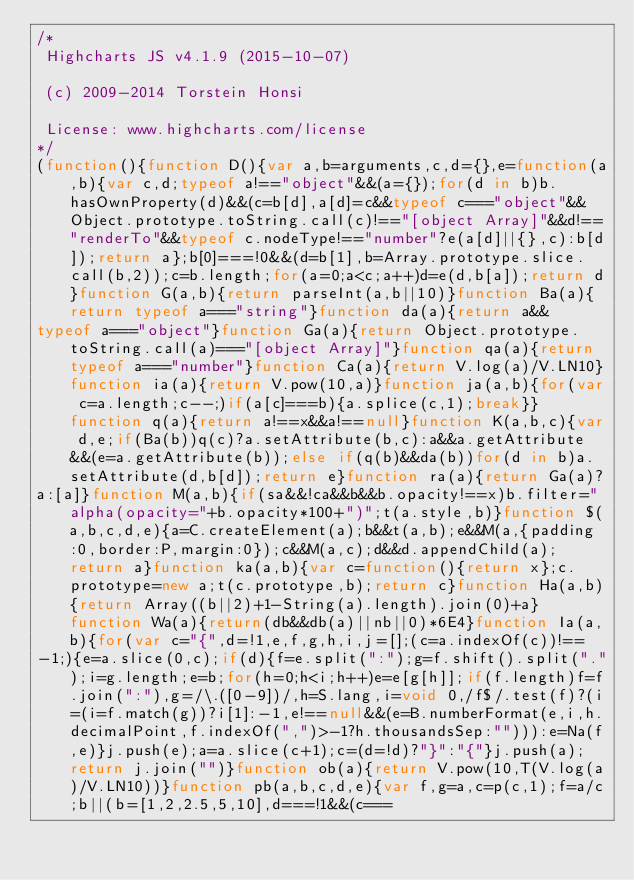<code> <loc_0><loc_0><loc_500><loc_500><_JavaScript_>/*
 Highcharts JS v4.1.9 (2015-10-07)

 (c) 2009-2014 Torstein Honsi

 License: www.highcharts.com/license
*/
(function(){function D(){var a,b=arguments,c,d={},e=function(a,b){var c,d;typeof a!=="object"&&(a={});for(d in b)b.hasOwnProperty(d)&&(c=b[d],a[d]=c&&typeof c==="object"&&Object.prototype.toString.call(c)!=="[object Array]"&&d!=="renderTo"&&typeof c.nodeType!=="number"?e(a[d]||{},c):b[d]);return a};b[0]===!0&&(d=b[1],b=Array.prototype.slice.call(b,2));c=b.length;for(a=0;a<c;a++)d=e(d,b[a]);return d}function G(a,b){return parseInt(a,b||10)}function Ba(a){return typeof a==="string"}function da(a){return a&&
typeof a==="object"}function Ga(a){return Object.prototype.toString.call(a)==="[object Array]"}function qa(a){return typeof a==="number"}function Ca(a){return V.log(a)/V.LN10}function ia(a){return V.pow(10,a)}function ja(a,b){for(var c=a.length;c--;)if(a[c]===b){a.splice(c,1);break}}function q(a){return a!==x&&a!==null}function K(a,b,c){var d,e;if(Ba(b))q(c)?a.setAttribute(b,c):a&&a.getAttribute&&(e=a.getAttribute(b));else if(q(b)&&da(b))for(d in b)a.setAttribute(d,b[d]);return e}function ra(a){return Ga(a)?
a:[a]}function M(a,b){if(sa&&!ca&&b&&b.opacity!==x)b.filter="alpha(opacity="+b.opacity*100+")";t(a.style,b)}function $(a,b,c,d,e){a=C.createElement(a);b&&t(a,b);e&&M(a,{padding:0,border:P,margin:0});c&&M(a,c);d&&d.appendChild(a);return a}function ka(a,b){var c=function(){return x};c.prototype=new a;t(c.prototype,b);return c}function Ha(a,b){return Array((b||2)+1-String(a).length).join(0)+a}function Wa(a){return(db&&db(a)||nb||0)*6E4}function Ia(a,b){for(var c="{",d=!1,e,f,g,h,i,j=[];(c=a.indexOf(c))!==
-1;){e=a.slice(0,c);if(d){f=e.split(":");g=f.shift().split(".");i=g.length;e=b;for(h=0;h<i;h++)e=e[g[h]];if(f.length)f=f.join(":"),g=/\.([0-9])/,h=S.lang,i=void 0,/f$/.test(f)?(i=(i=f.match(g))?i[1]:-1,e!==null&&(e=B.numberFormat(e,i,h.decimalPoint,f.indexOf(",")>-1?h.thousandsSep:""))):e=Na(f,e)}j.push(e);a=a.slice(c+1);c=(d=!d)?"}":"{"}j.push(a);return j.join("")}function ob(a){return V.pow(10,T(V.log(a)/V.LN10))}function pb(a,b,c,d,e){var f,g=a,c=p(c,1);f=a/c;b||(b=[1,2,2.5,5,10],d===!1&&(c===</code> 